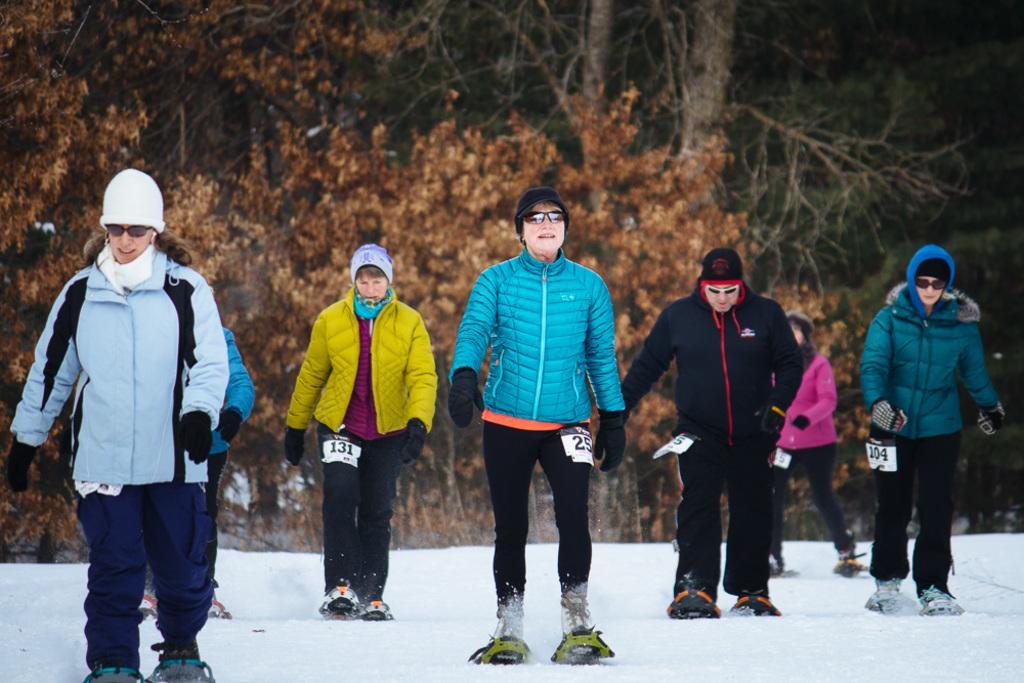Could you give a brief overview of what you see in this image? In this image we can see a group of people standing in the snow wearing the skis. On the backside we can see a group of trees. 